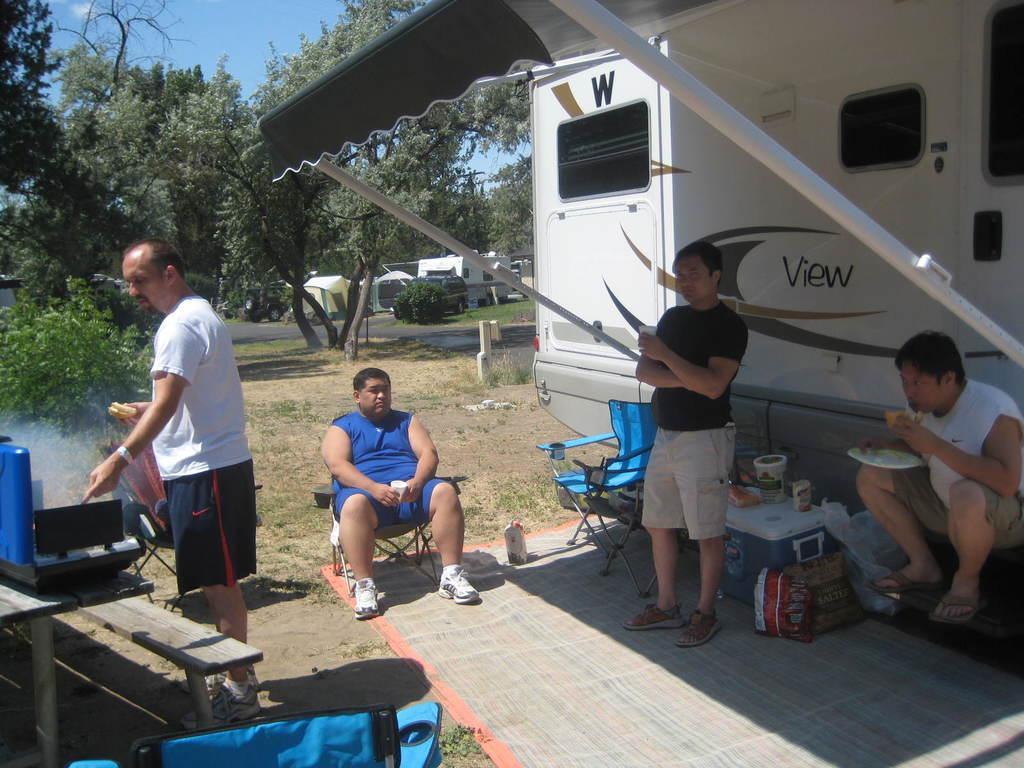Could you give a brief overview of what you see in this image? There is a man on the left side of the image, it seems like he is grilling and there is a wooden bench and a bag in the bottom left side and there is a man who is sitting on a chair in the center and there are two men on the right side, there are some items, chair, roof and vehicle on the right side. There are trees, tents, vehicles and sky in the background area. 